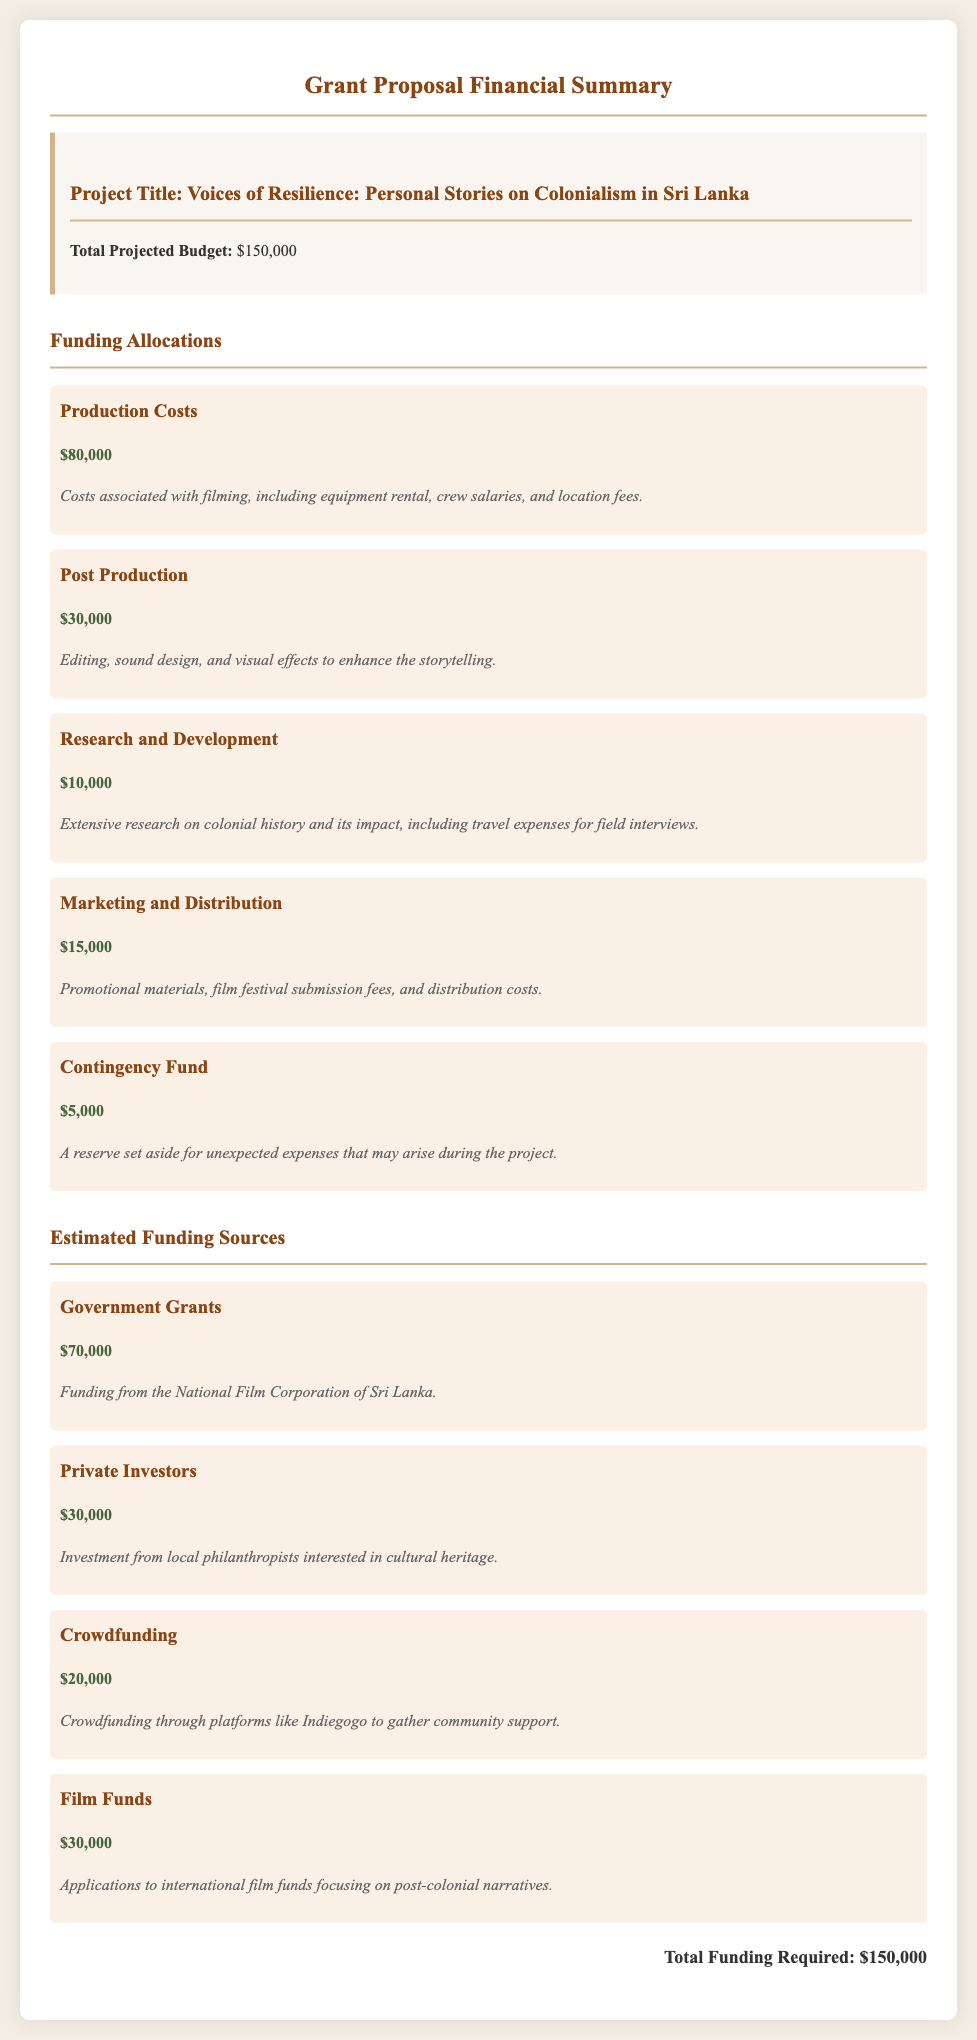what is the project title? The project title is stated at the top of the funding allocations section, which identifies the focus of the film.
Answer: Voices of Resilience: Personal Stories on Colonialism in Sri Lanka how much is allocated for production costs? The production costs are listed under funding allocations and detail the expenses intended for filming.
Answer: $80,000 what percentage of the total budget is allocated for post production? The post production allocation is $30,000, which corresponds to a calculation based on the total budget of $150,000.
Answer: 20% what is the amount for the contingency fund? The contingency fund amount is directly specified within the funding allocations section.
Answer: $5,000 which funding source contributes the most? The funding sources section lists various contributors, and the government grants represent the highest amount.
Answer: Government Grants how much total funding is required for the project? The total funding required is clearly stated at the end of the document as the sum of all allocations.
Answer: $150,000 what part of the budget is designated for research and development? The funding allocation for research and development is specifically detailed.
Answer: $10,000 who is providing funding from private investors? The private investors contribution is mentioned in the estimated funding sources, identifying the type of contributors involved.
Answer: Local philanthropists how much is expected from crowdfunding? The crowdfunding amount is explicitly stated under the estimated funding sources section.
Answer: $20,000 